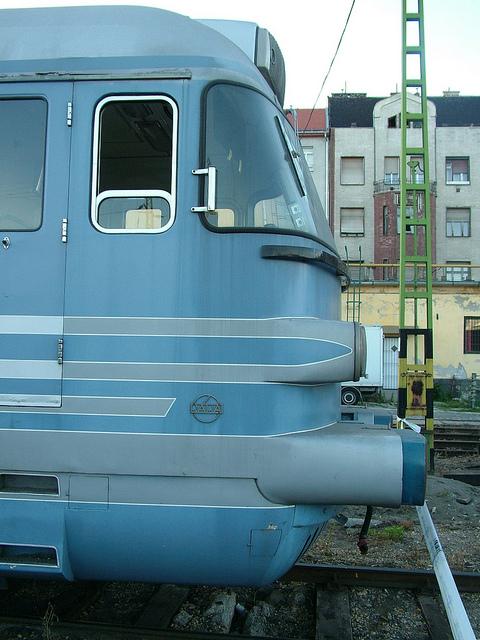What type of building is in the background?
Be succinct. Apartment. Is the vehicle moving?
Write a very short answer. No. Is this a train or bus?
Concise answer only. Train. 